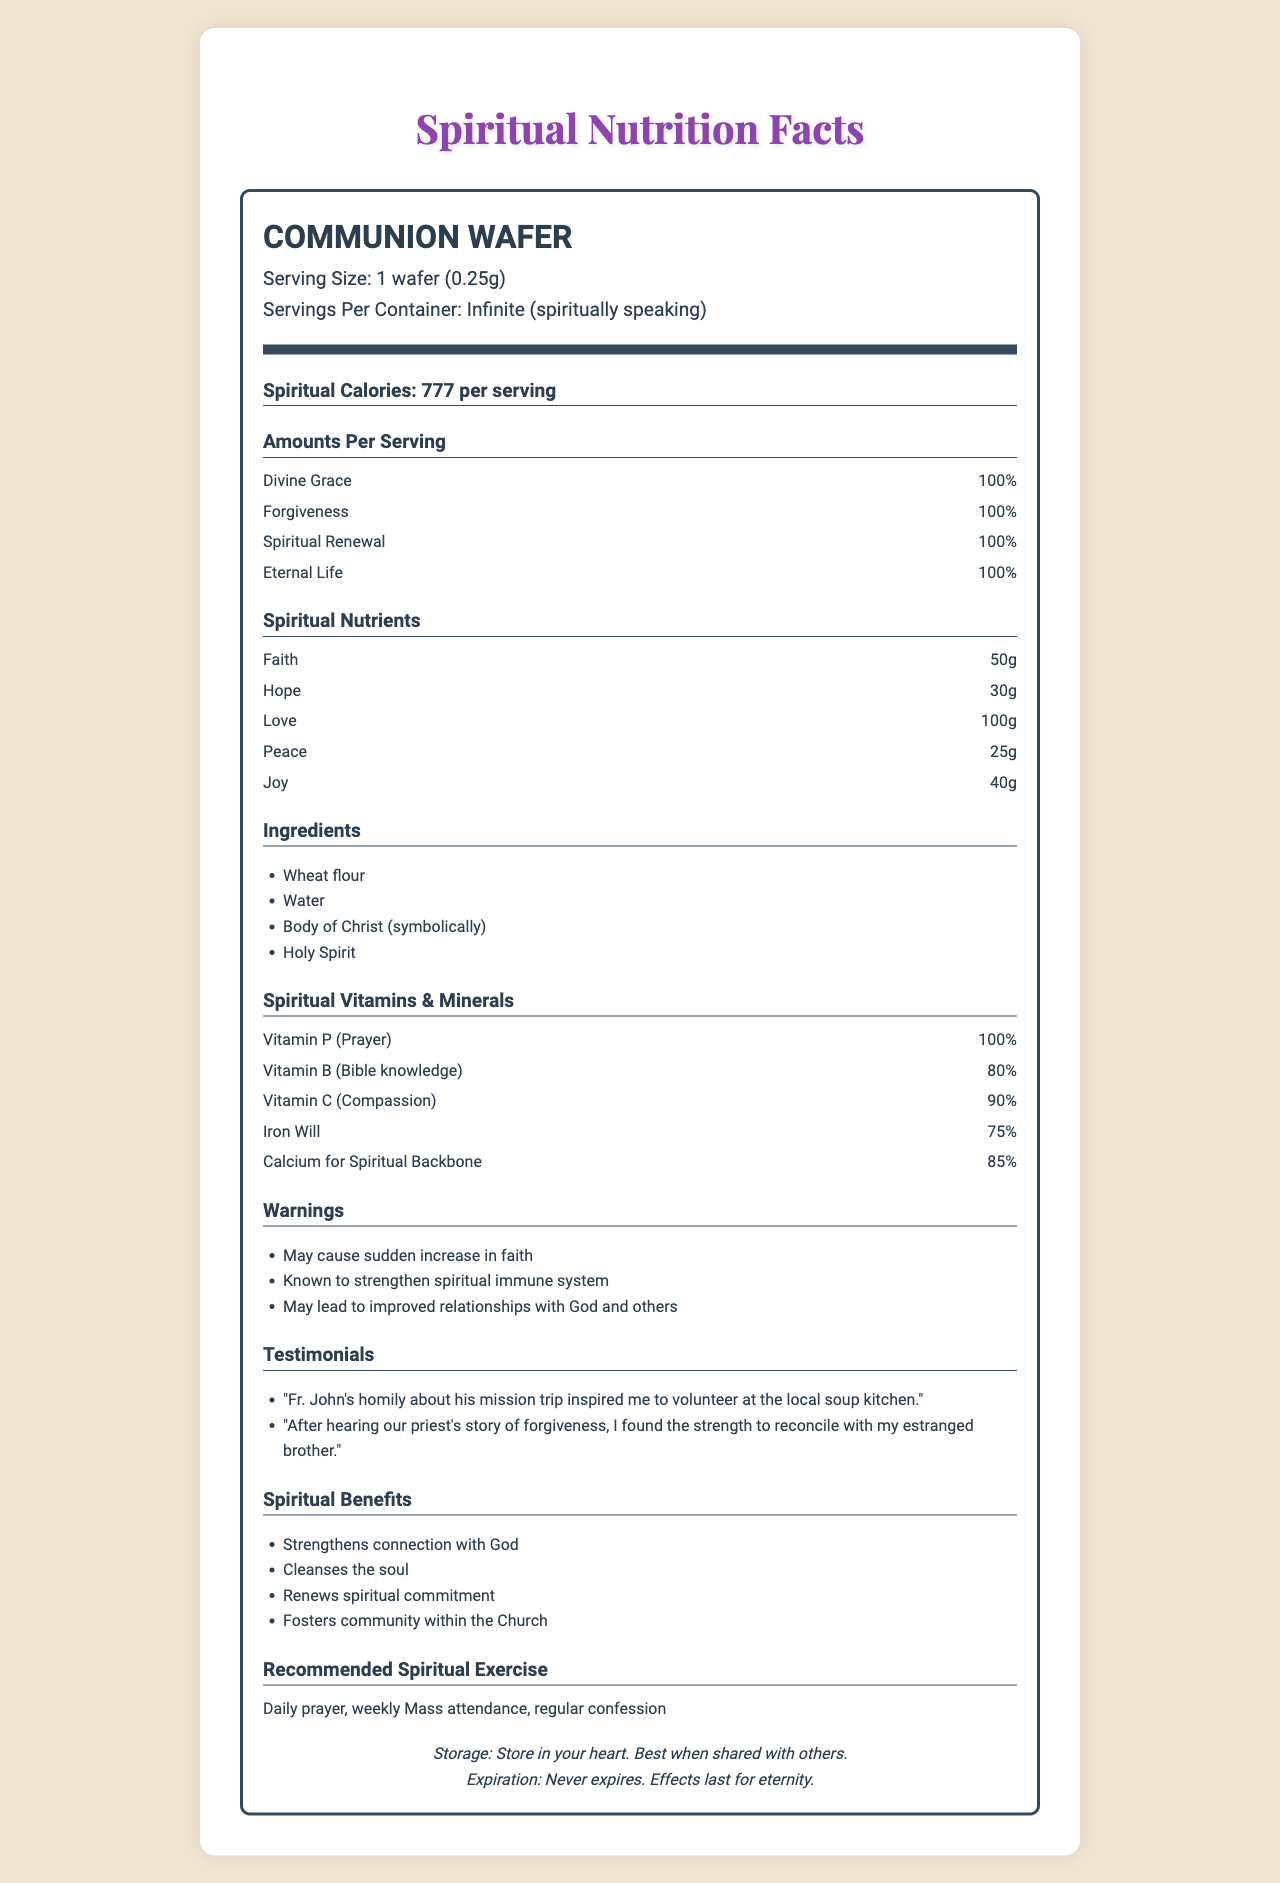what is the serving size of the communion wafer? The document lists "Serving Size" right at the top of the nutrition label section as "1 wafer (0.25g)".
Answer: 1 wafer (0.25g) what is the spiritual calorie count per serving? The "Spiritual Calories" are prominently mentioned under the nutrient group section of the document.
Answer: 777 per serving what percentage of Divine Grace is provided per serving? Under the "Amounts Per Serving" section, Divine Grace is listed with a value of "100%".
Answer: 100% which spiritual nutrient is present in the highest amount? A. Peace B. Faith C. Love D. Hope In the "Spiritual Nutrients" section, Love has the highest listed amount of 100g.
Answer: C. Love what warning is provided regarding the consumption of communion wafers? The "Warnings" section lists "May cause sudden increase in faith" as its first point.
Answer: May cause sudden increase in faith which ingredient is included symbolically in communion wafers? The "Ingredients" list includes "Body of Christ (symbolically)".
Answer: Body of Christ what spiritual vitamin is provided at 80% per serving? The "Spiritual Vitamins & Minerals" section lists Vitamin B (Bible knowledge) at 80%.
Answer: Vitamin B (Bible knowledge) what testimonials are provided in the document? The "Testimonials" section provides these two specific examples.
Answer: Fr. John's homily about his mission trip inspired me to volunteer at the local soup kitchen. After hearing our priest's story of forgiveness, I found the strength to reconcile with my estranged brother. what is the recommended spiritual exercise according to the document? This recommendation is found under the "Recommended Spiritual Exercise" section.
Answer: Daily prayer, weekly Mass attendance, regular confession how does the document suggest you store the communion wafers? The "Storage" section provides this poetic suggestion.
Answer: Store in your heart. Best when shared with others. what is one of the spiritual benefits of consuming communion wafers, according to the document? The "Spiritual Benefits" section lists several points, one of which is "Strengthens connection with God".
Answer: Strengthens connection with God does the document indicate an expiration date for the communion wafers? The "Expiration" section mentions that it "Never expires. Effects last for eternity."
Answer: No what nutritious ingredient might lead to improved relationships with others and God? The "Ingredients" section lists the "Holy Spirit," and this idea is amplified in the "Warnings" section which mentions improved relationships.
Answer: Holy Spirit is Vitamin P (Prayer) fully satisfied in a single serving? The "Spiritual Vitamins & Minerals" section specifies Vitamin P (Prayer) at 100%.
Answer: Yes summarize the main idea of the document. The spiritual nutrition facts label crafts a parallel between physical nutrition labels and spiritual nourishment, designed humorously but with the intent to reflect the profound impacts of sacramental communion on an individual's faith journey.
Answer: The document is a spiritual analysis of communion wafers, emphasizing their deep significance in providing spiritual nourishment through divine grace, forgiveness, spiritual renewal, and eternal life. It outlines various spiritual nutrients, ingredients, benefits, and recommendations for spiritual exercise while highlighting the everlasting impact and benefits of partaking in communion. what spiritual exercise is recommended alongside consuming communion wafers? The document provides general spiritual benefits but does not list a specific exercise to accompany consumption directly.
Answer: I don't know what role does "Holy Spirit" play in the ingredients of the communion wafer? The document lists "Holy Spirit" as an ingredient but doesn't elaborate on its specific role or function within the context of the communion wafer.
Answer: Not enough information 